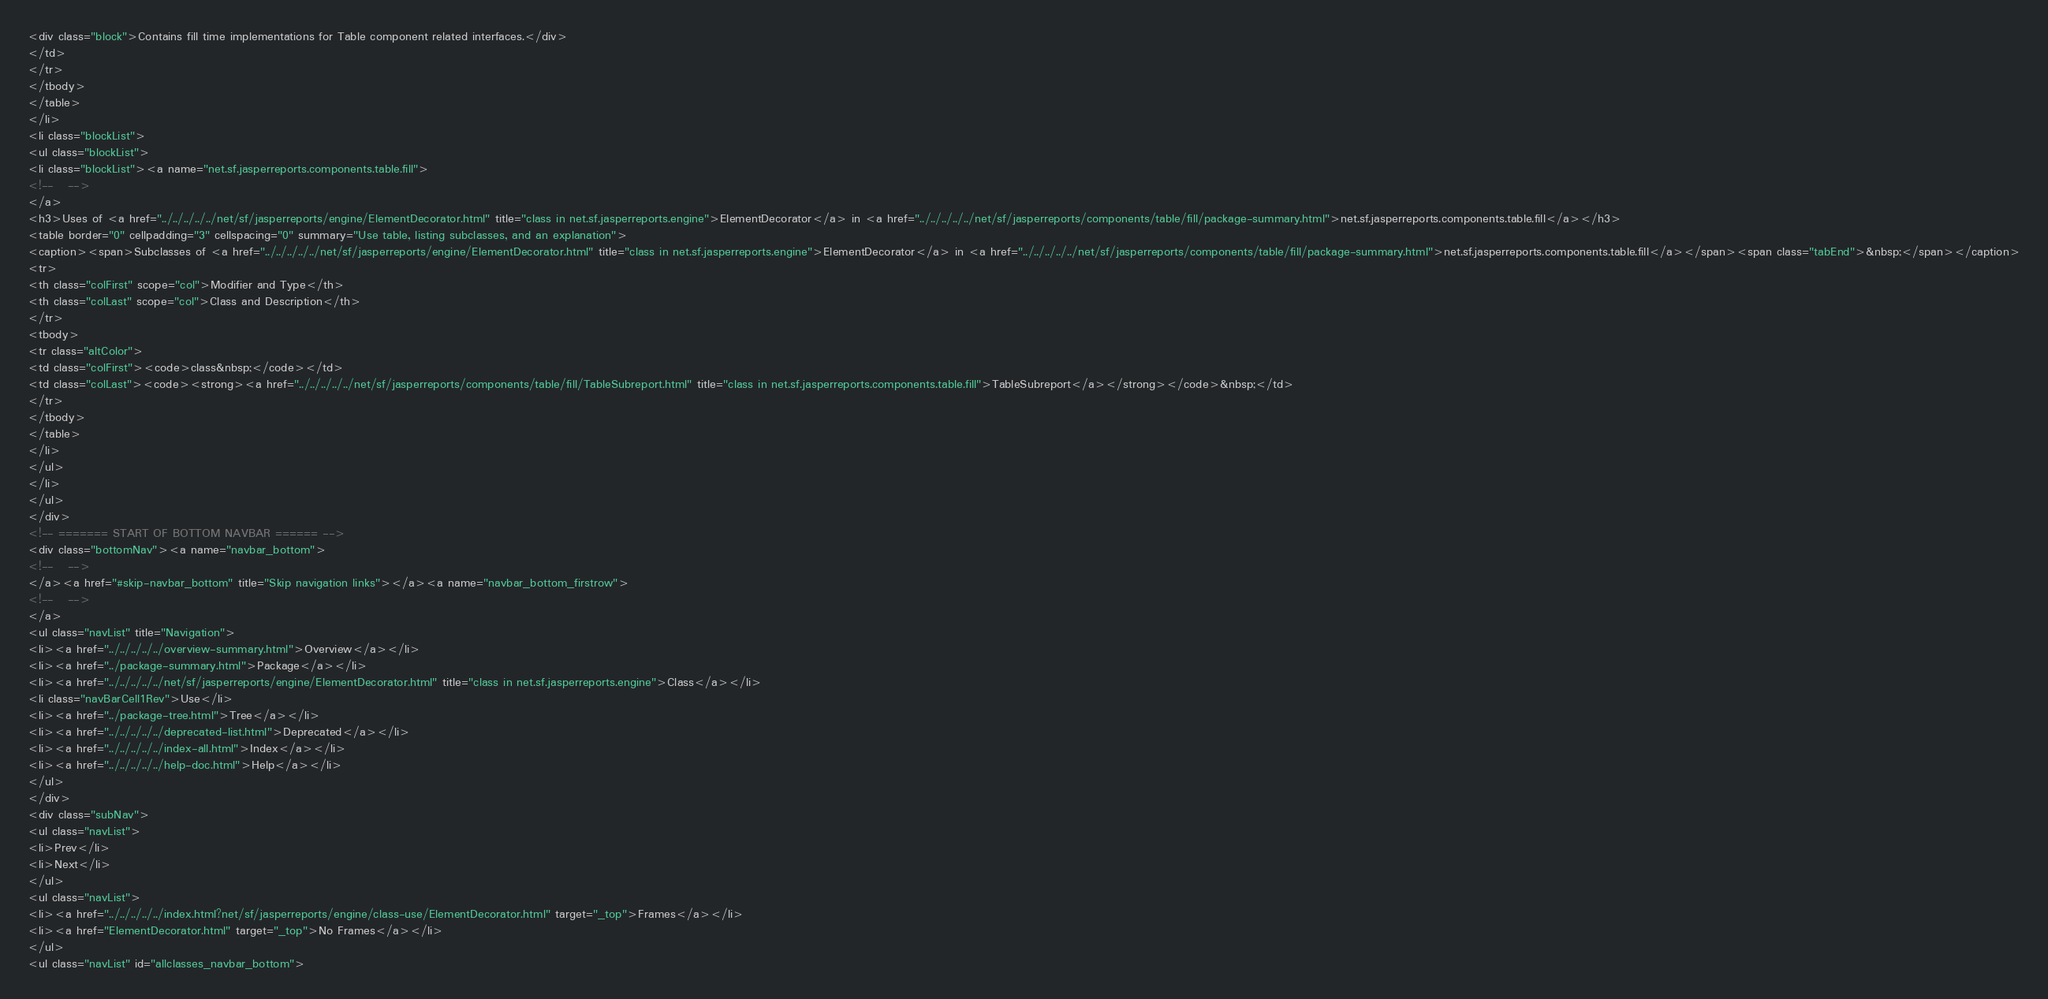Convert code to text. <code><loc_0><loc_0><loc_500><loc_500><_HTML_><div class="block">Contains fill time implementations for Table component related interfaces.</div>
</td>
</tr>
</tbody>
</table>
</li>
<li class="blockList">
<ul class="blockList">
<li class="blockList"><a name="net.sf.jasperreports.components.table.fill">
<!--   -->
</a>
<h3>Uses of <a href="../../../../../net/sf/jasperreports/engine/ElementDecorator.html" title="class in net.sf.jasperreports.engine">ElementDecorator</a> in <a href="../../../../../net/sf/jasperreports/components/table/fill/package-summary.html">net.sf.jasperreports.components.table.fill</a></h3>
<table border="0" cellpadding="3" cellspacing="0" summary="Use table, listing subclasses, and an explanation">
<caption><span>Subclasses of <a href="../../../../../net/sf/jasperreports/engine/ElementDecorator.html" title="class in net.sf.jasperreports.engine">ElementDecorator</a> in <a href="../../../../../net/sf/jasperreports/components/table/fill/package-summary.html">net.sf.jasperreports.components.table.fill</a></span><span class="tabEnd">&nbsp;</span></caption>
<tr>
<th class="colFirst" scope="col">Modifier and Type</th>
<th class="colLast" scope="col">Class and Description</th>
</tr>
<tbody>
<tr class="altColor">
<td class="colFirst"><code>class&nbsp;</code></td>
<td class="colLast"><code><strong><a href="../../../../../net/sf/jasperreports/components/table/fill/TableSubreport.html" title="class in net.sf.jasperreports.components.table.fill">TableSubreport</a></strong></code>&nbsp;</td>
</tr>
</tbody>
</table>
</li>
</ul>
</li>
</ul>
</div>
<!-- ======= START OF BOTTOM NAVBAR ====== -->
<div class="bottomNav"><a name="navbar_bottom">
<!--   -->
</a><a href="#skip-navbar_bottom" title="Skip navigation links"></a><a name="navbar_bottom_firstrow">
<!--   -->
</a>
<ul class="navList" title="Navigation">
<li><a href="../../../../../overview-summary.html">Overview</a></li>
<li><a href="../package-summary.html">Package</a></li>
<li><a href="../../../../../net/sf/jasperreports/engine/ElementDecorator.html" title="class in net.sf.jasperreports.engine">Class</a></li>
<li class="navBarCell1Rev">Use</li>
<li><a href="../package-tree.html">Tree</a></li>
<li><a href="../../../../../deprecated-list.html">Deprecated</a></li>
<li><a href="../../../../../index-all.html">Index</a></li>
<li><a href="../../../../../help-doc.html">Help</a></li>
</ul>
</div>
<div class="subNav">
<ul class="navList">
<li>Prev</li>
<li>Next</li>
</ul>
<ul class="navList">
<li><a href="../../../../../index.html?net/sf/jasperreports/engine/class-use/ElementDecorator.html" target="_top">Frames</a></li>
<li><a href="ElementDecorator.html" target="_top">No Frames</a></li>
</ul>
<ul class="navList" id="allclasses_navbar_bottom"></code> 